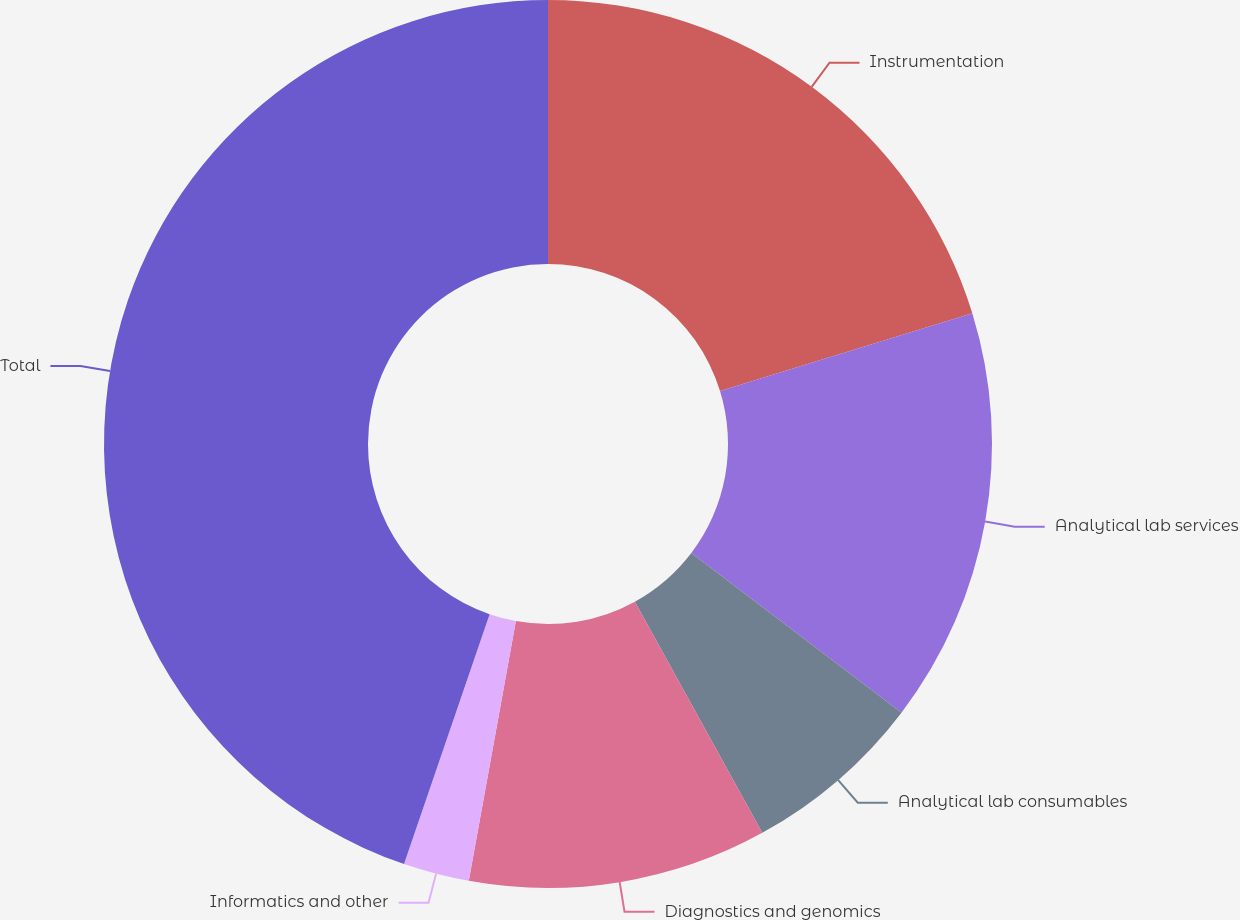Convert chart. <chart><loc_0><loc_0><loc_500><loc_500><pie_chart><fcel>Instrumentation<fcel>Analytical lab services<fcel>Analytical lab consumables<fcel>Diagnostics and genomics<fcel>Informatics and other<fcel>Total<nl><fcel>20.24%<fcel>15.1%<fcel>6.64%<fcel>10.87%<fcel>2.4%<fcel>44.74%<nl></chart> 